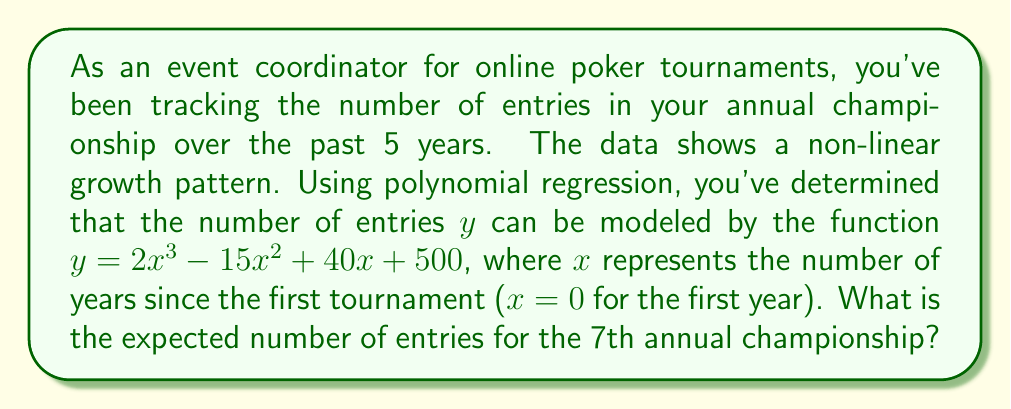Give your solution to this math problem. To solve this problem, we need to use the given polynomial function and substitute x = 6 (since the 7th year is 6 years after the first tournament). Let's break it down step by step:

1) The given function is:
   $y = 2x^3 - 15x^2 + 40x + 500$

2) We need to calculate y when x = 6:
   $y = 2(6)^3 - 15(6)^2 + 40(6) + 500$

3) Let's calculate each term:
   - $2(6)^3 = 2 * 216 = 432$
   - $15(6)^2 = 15 * 36 = 540$
   - $40(6) = 240$
   - The constant term is 500

4) Now, let's substitute these values into the equation:
   $y = 432 - 540 + 240 + 500$

5) Simplify:
   $y = 632$

Therefore, the expected number of entries for the 7th annual championship is 632.
Answer: 632 entries 